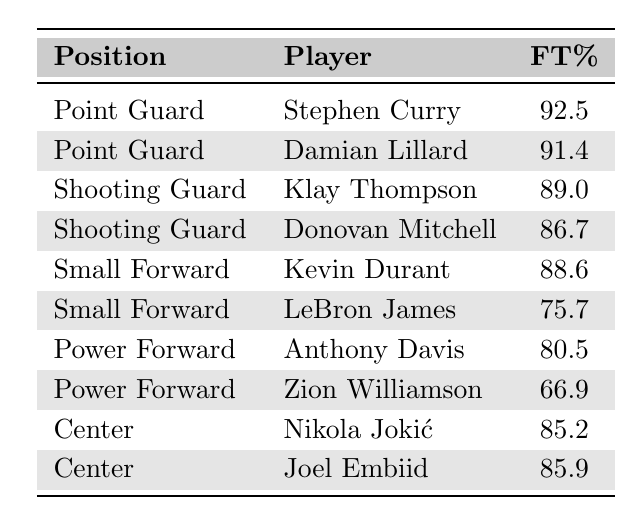What's the free throw percentage of Stephen Curry? Stephen Curry's statistics are listed under the "Point Guard" position, and his free throw percentage is shown as 92.5.
Answer: 92.5 Which player has the lowest free throw percentage? The "Power Forward" position has Zion Williamson with a free throw percentage of 66.9, which is the lowest among all players listed.
Answer: 66.9 What is the average free throw percentage for all players listed? To find the average, sum the free throw percentages: (92.5 + 91.4 + 89.0 + 86.7 + 88.6 + 80.5 + 66.9 + 85.2 + 85.9 + 75.7) = 866.4. There are 10 players, so the average is 866.4 / 10 = 86.64.
Answer: 86.64 Does Kevin Durant have a higher free throw percentage than LeBron James? Kevin Durant's free throw percentage is 88.6, while LeBron James has 75.7. Since 88.6 is greater than 75.7, the answer is yes.
Answer: Yes Which position has the highest average free throw percentage? Calculate the average for each position: Point Guards (92.5 + 91.4) / 2 = 91.95; Shooting Guards (89.0 + 86.7) / 2 = 87.85; Small Forwards (88.6 + 75.7) / 2 = 82.15; Power Forwards (80.5 + 66.9) / 2 = 73.7; Centers (85.2 + 85.9) / 2 = 85.55. Point Guards have the highest average of 91.95.
Answer: Point Guard What is the difference in free throw percentage between the best and worst players on the list? The best player is Stephen Curry with 92.5 and the worst is Zion Williamson with 66.9. The difference is 92.5 - 66.9 = 25.6.
Answer: 25.6 How many players have a free throw percentage above 85? The players with percentages above 85 are Stephen Curry, Damian Lillard, Klay Thompson, Kevin Durant, Nikola Jokić, and Joel Embiid. Counting these gives a total of 6 players.
Answer: 6 Is LeBron James in the top half of free throw percentages among the players listed? LeBron James’ percentage is 75.7. The median of the percentages is 85.5. Since 75.7 is below the median, he is not in the top half.
Answer: No If we combine the free throw percentages of both centers, how do they compare to the shooting guards? Adding the centers' percentages gives 85.2 + 85.9 = 171.1; for shooting guards, 89.0 + 86.7 = 175.7. Comparing, 171.1 is less than 175.7.
Answer: Less 